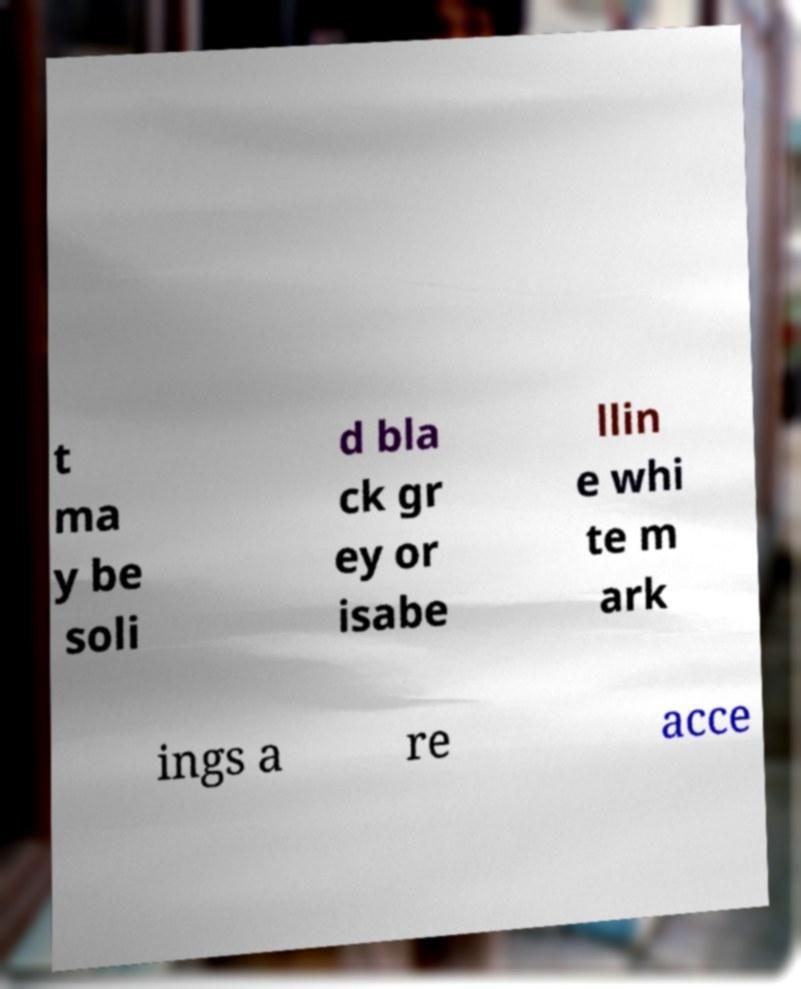Could you assist in decoding the text presented in this image and type it out clearly? t ma y be soli d bla ck gr ey or isabe llin e whi te m ark ings a re acce 